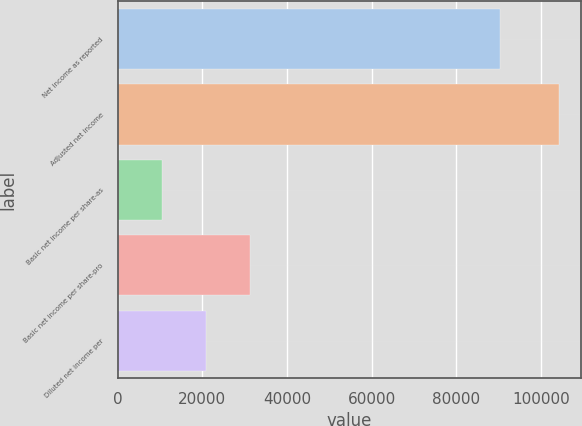Convert chart. <chart><loc_0><loc_0><loc_500><loc_500><bar_chart><fcel>Net income as reported<fcel>Adjusted net income<fcel>Basic net income per share-as<fcel>Basic net income per share-pro<fcel>Diluted net income per<nl><fcel>90313<fcel>104225<fcel>10423.2<fcel>31268.1<fcel>20845.6<nl></chart> 